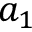Convert formula to latex. <formula><loc_0><loc_0><loc_500><loc_500>a _ { 1 }</formula> 